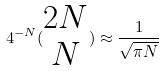<formula> <loc_0><loc_0><loc_500><loc_500>4 ^ { - N } ( \begin{matrix} 2 N \\ N \end{matrix} ) \approx \frac { 1 } { \sqrt { \pi N } }</formula> 